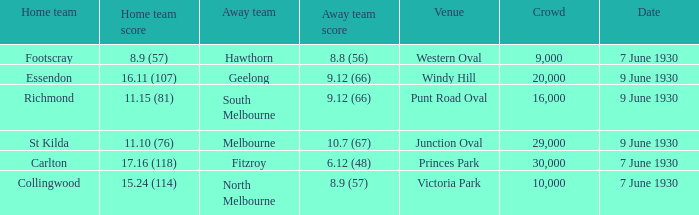What away team played Footscray? Hawthorn. 